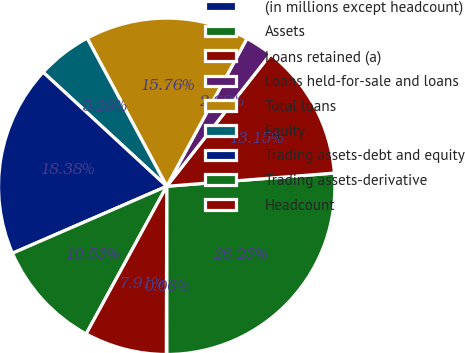Convert chart to OTSL. <chart><loc_0><loc_0><loc_500><loc_500><pie_chart><fcel>(in millions except headcount)<fcel>Assets<fcel>Loans retained (a)<fcel>Loans held-for-sale and loans<fcel>Total loans<fcel>Equity<fcel>Trading assets-debt and equity<fcel>Trading assets-derivative<fcel>Headcount<nl><fcel>0.06%<fcel>26.23%<fcel>13.15%<fcel>2.68%<fcel>15.76%<fcel>5.29%<fcel>18.38%<fcel>10.53%<fcel>7.91%<nl></chart> 